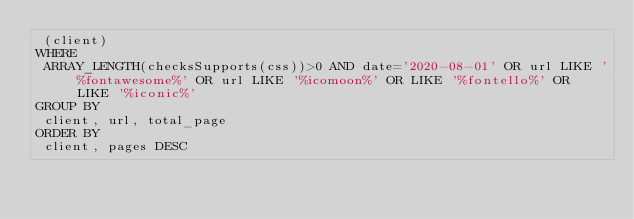<code> <loc_0><loc_0><loc_500><loc_500><_SQL_> (client)
WHERE
 ARRAY_LENGTH(checksSupports(css))>0 AND date='2020-08-01' OR url LIKE '%fontawesome%' OR url LIKE '%icomoon%' OR LIKE '%fontello%' OR LIKE '%iconic%'  
GROUP BY
 client, url, total_page
ORDER BY
 client, pages DESC
</code> 